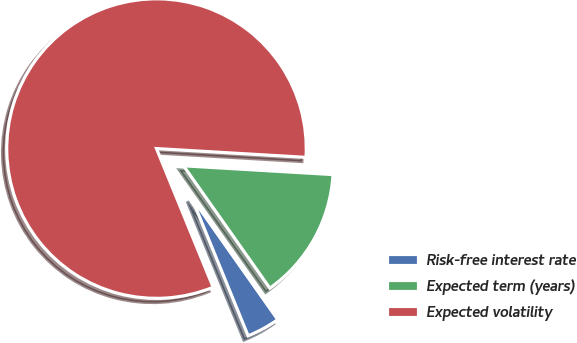Convert chart to OTSL. <chart><loc_0><loc_0><loc_500><loc_500><pie_chart><fcel>Risk-free interest rate<fcel>Expected term (years)<fcel>Expected volatility<nl><fcel>3.6%<fcel>14.29%<fcel>82.11%<nl></chart> 